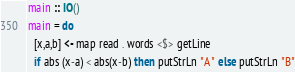Convert code to text. <code><loc_0><loc_0><loc_500><loc_500><_Haskell_>main :: IO()
main = do
  [x,a,b] <- map read . words <$> getLine
  if abs (x-a) < abs(x-b) then putStrLn "A" else putStrLn "B"</code> 